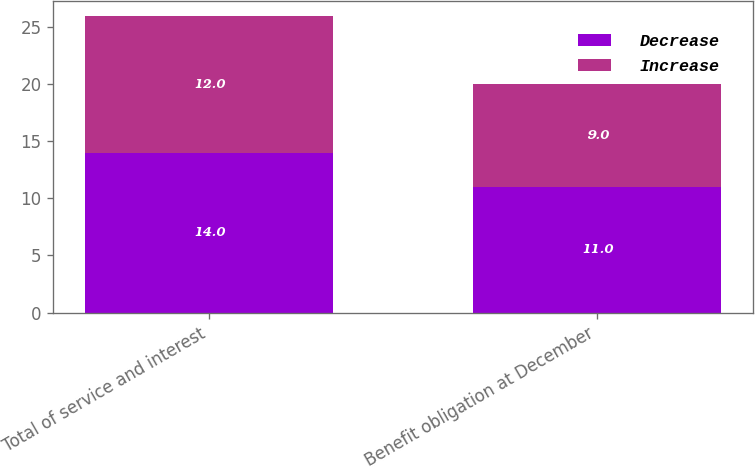Convert chart to OTSL. <chart><loc_0><loc_0><loc_500><loc_500><stacked_bar_chart><ecel><fcel>Total of service and interest<fcel>Benefit obligation at December<nl><fcel>Decrease<fcel>14<fcel>11<nl><fcel>Increase<fcel>12<fcel>9<nl></chart> 